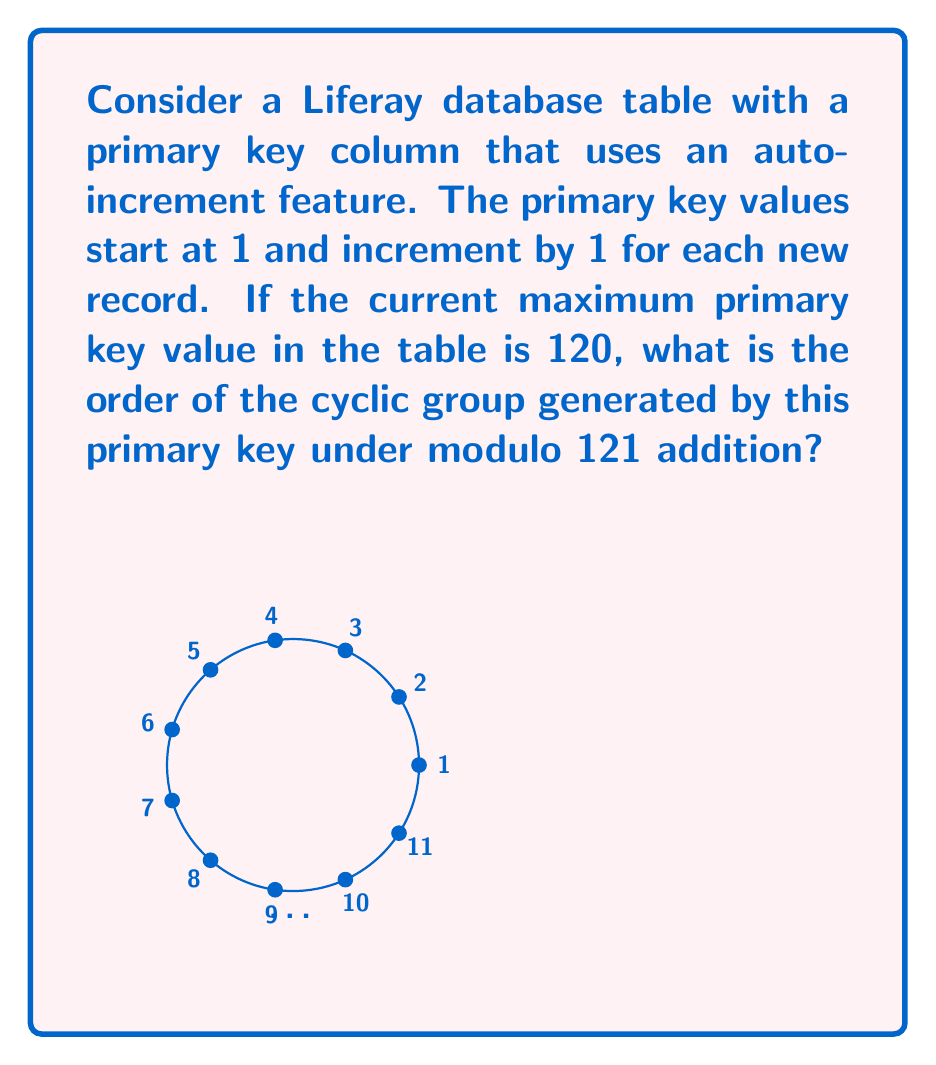Teach me how to tackle this problem. Let's approach this step-by-step:

1) In group theory, the order of an element in a cyclic group is the smallest positive integer $n$ such that $a^n = e$, where $a$ is the generator and $e$ is the identity element.

2) In this case, we're dealing with modulo 121 addition. The group operation is addition modulo 121, and the identity element is 0.

3) The generator of our cyclic group is 1 (the smallest possible primary key value).

4) We need to find the smallest positive integer $n$ such that:

   $1 + 1 + ... + 1$ (n times) $\equiv 0 \pmod{121}$

   Or equivalently: $n \equiv 0 \pmod{121}$

5) Since 121 is prime (121 = 11 * 11), and 1 is coprime to 121, the order of the cyclic group will be equal to 121.

6) This means that the cyclic group generated by the primary key will include all integers from 0 to 120 modulo 121.

7) Interestingly, this also implies that regardless of the current maximum primary key value (120 in this case), as long as we're working modulo 121, the order of the cyclic group remains 121.
Answer: 121 